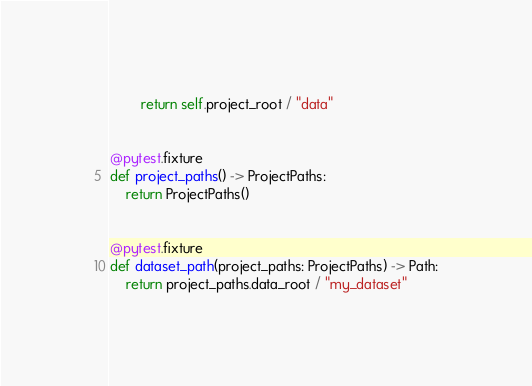Convert code to text. <code><loc_0><loc_0><loc_500><loc_500><_Python_>        return self.project_root / "data"


@pytest.fixture
def project_paths() -> ProjectPaths:
    return ProjectPaths()


@pytest.fixture
def dataset_path(project_paths: ProjectPaths) -> Path:
    return project_paths.data_root / "my_dataset"
</code> 